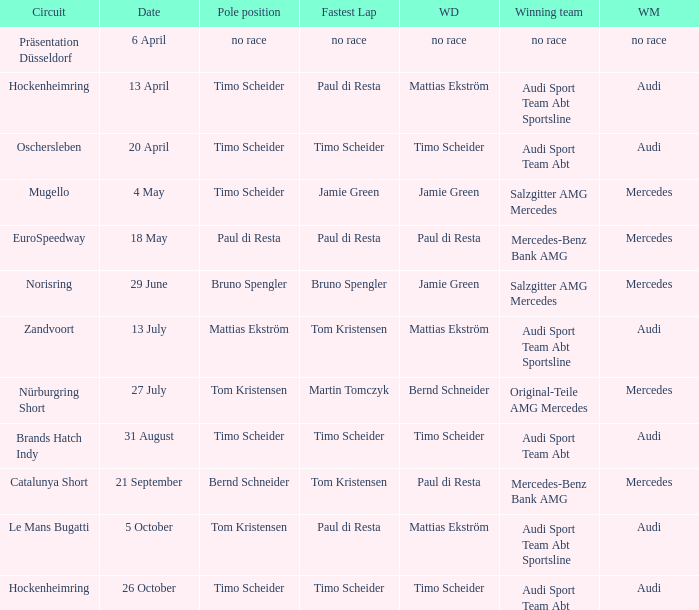What is the fastest lap in the Le Mans Bugatti circuit? Paul di Resta. 